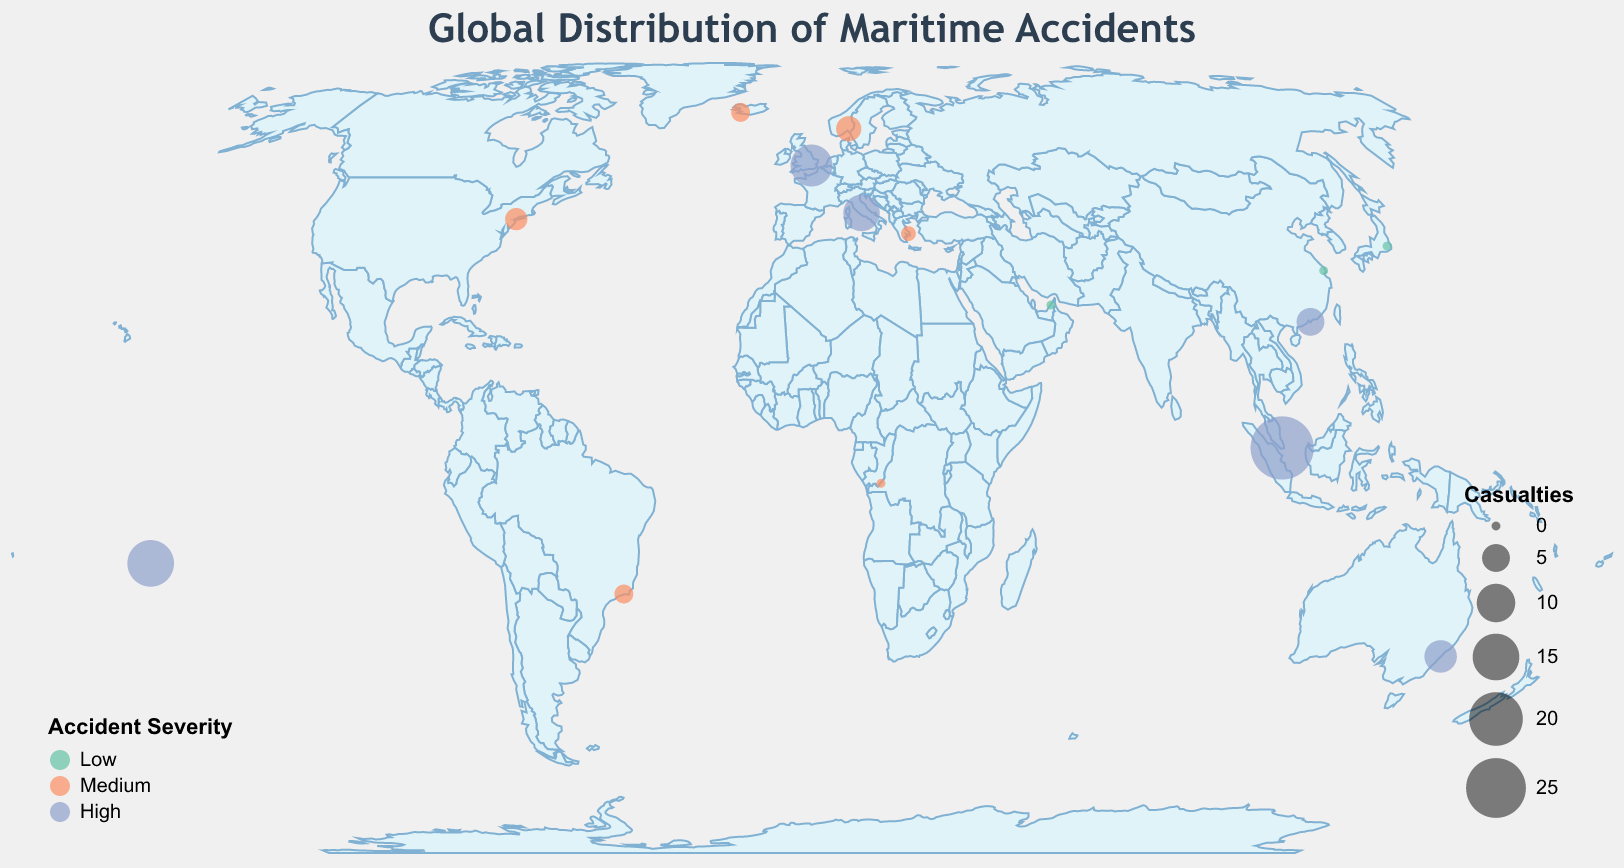What is the title of the figure? The title is usually displayed at the top of the figure and often summarizes the content being presented. Here, it reads "Global Distribution of Maritime Accidents."
Answer: Global Distribution of Maritime Accidents What color represents high severity accidents? In the figure, the legend explains the color coding used to depict accident severity. The color for high severity is blue.
Answer: Blue How many accidents occurred in 2019 according to the plot? To find the number of accidents in 2019, identify data points with the year 2019. There are three such points: one in New York (Fire), one in Hong Kong (Structural Failure), and one in Tahiti (Weather Damage).
Answer: Three Which location had the highest number of casualties and what was the accident type? By looking at the size of the circles on the map, the largest circle represents the highest number of casualties. This circle is located near Singapore for a Capsizing accident.
Answer: Singapore, Capsizing What accident type occurred in Southern Hemisphere with medium severity and no casualties? To locate this information, identify the circles in the Southern Hemisphere with medium severity color and check for no casualties. The Pollution Incident near Kinshasa matches these criteria.
Answer: Pollution Incident Compare the severity of accidents in London and Sydney. Which one is higher? London shows a Collision accident and Sydney shows an Explosion accident. Based on the colors, both are high severity. Thus, they have equal severity.
Answer: Equal Which accident type had the lowest casualties and what was the year? Identify the smallest circles representing the lowest casualties, which occur at zero casualties. The years for these incidents are Grounding (2020), Machinery Failure (2022), Allision (2022), and Pollution Incident (2020). The accident type with the year 2020 is Grounding.
Answer: Grounding, 2020 Compare the number of high-severity accidents against medium-severity accidents. Which type is more frequent? Count circles color-coded for high severity (blue) and medium severity (orange). There are six high-severity (Collision, Capsizing, Explosion, Flooding, Structural Failure, Weather Damage) and six medium-severity (Fire, Man Overboard, Cargo Shift, Piracy, Pollution Incident, Ice Damage) accidents. Both severities occur equally.
Answer: Equal How does the distribution of accidents vary based on latitude? To analyze this, observe the spread of circles across different latitudes. Accidents occur both in the Northern hemisphere and spread evenly to the Southern hemisphere, indicating no strong latitudinal bias.
Answer: Even distribution across latitudes What is the primary factor that influences the size of the circles in the figure? The figure legend indicates that the size of the circles correlates with the number of casualties. Larger circles denote higher casualties.
Answer: Casualties 